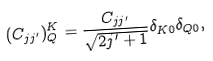<formula> <loc_0><loc_0><loc_500><loc_500>( C _ { j j ^ { \prime } } ) ^ { K } _ { Q } = \frac { C _ { j j ^ { \prime } } } { \sqrt { 2 j ^ { \prime } + 1 } } \delta _ { K 0 } \delta _ { Q 0 } ,</formula> 